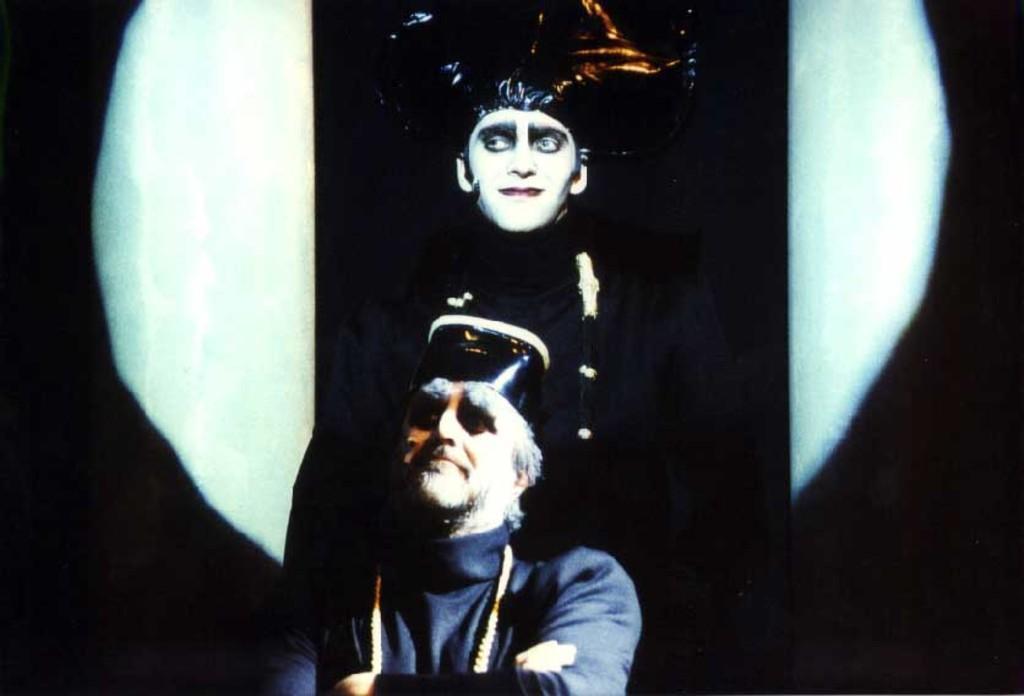How would you summarize this image in a sentence or two? In this image I see 2 men and I see that it is white and black in the background. 